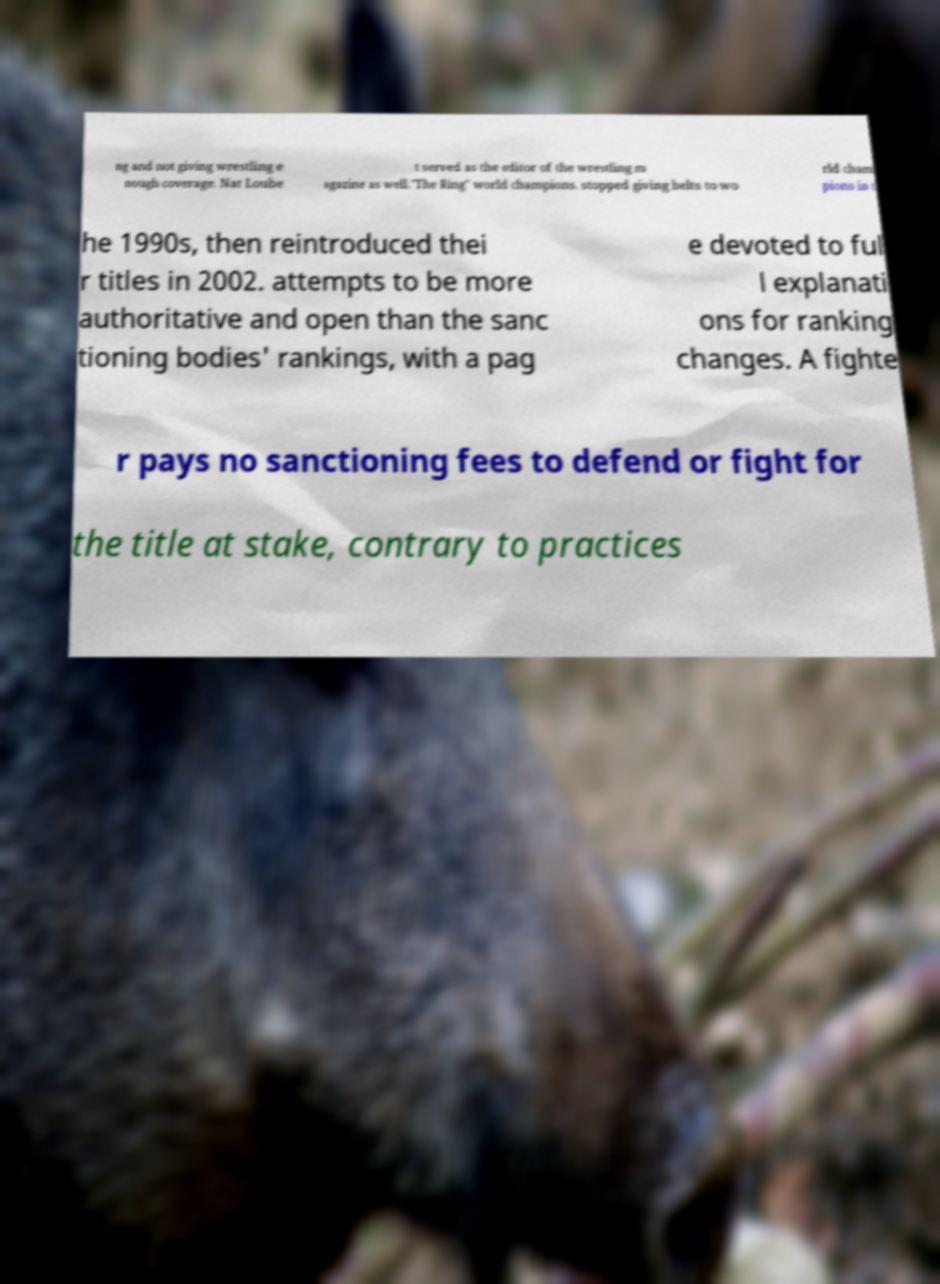What messages or text are displayed in this image? I need them in a readable, typed format. ng and not giving wrestling e nough coverage. Nat Loube t served as the editor of the wrestling m agazine as well."The Ring" world champions. stopped giving belts to wo rld cham pions in t he 1990s, then reintroduced thei r titles in 2002. attempts to be more authoritative and open than the sanc tioning bodies' rankings, with a pag e devoted to ful l explanati ons for ranking changes. A fighte r pays no sanctioning fees to defend or fight for the title at stake, contrary to practices 